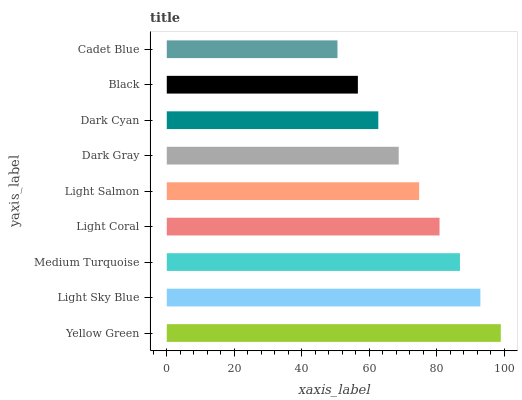Is Cadet Blue the minimum?
Answer yes or no. Yes. Is Yellow Green the maximum?
Answer yes or no. Yes. Is Light Sky Blue the minimum?
Answer yes or no. No. Is Light Sky Blue the maximum?
Answer yes or no. No. Is Yellow Green greater than Light Sky Blue?
Answer yes or no. Yes. Is Light Sky Blue less than Yellow Green?
Answer yes or no. Yes. Is Light Sky Blue greater than Yellow Green?
Answer yes or no. No. Is Yellow Green less than Light Sky Blue?
Answer yes or no. No. Is Light Salmon the high median?
Answer yes or no. Yes. Is Light Salmon the low median?
Answer yes or no. Yes. Is Black the high median?
Answer yes or no. No. Is Medium Turquoise the low median?
Answer yes or no. No. 